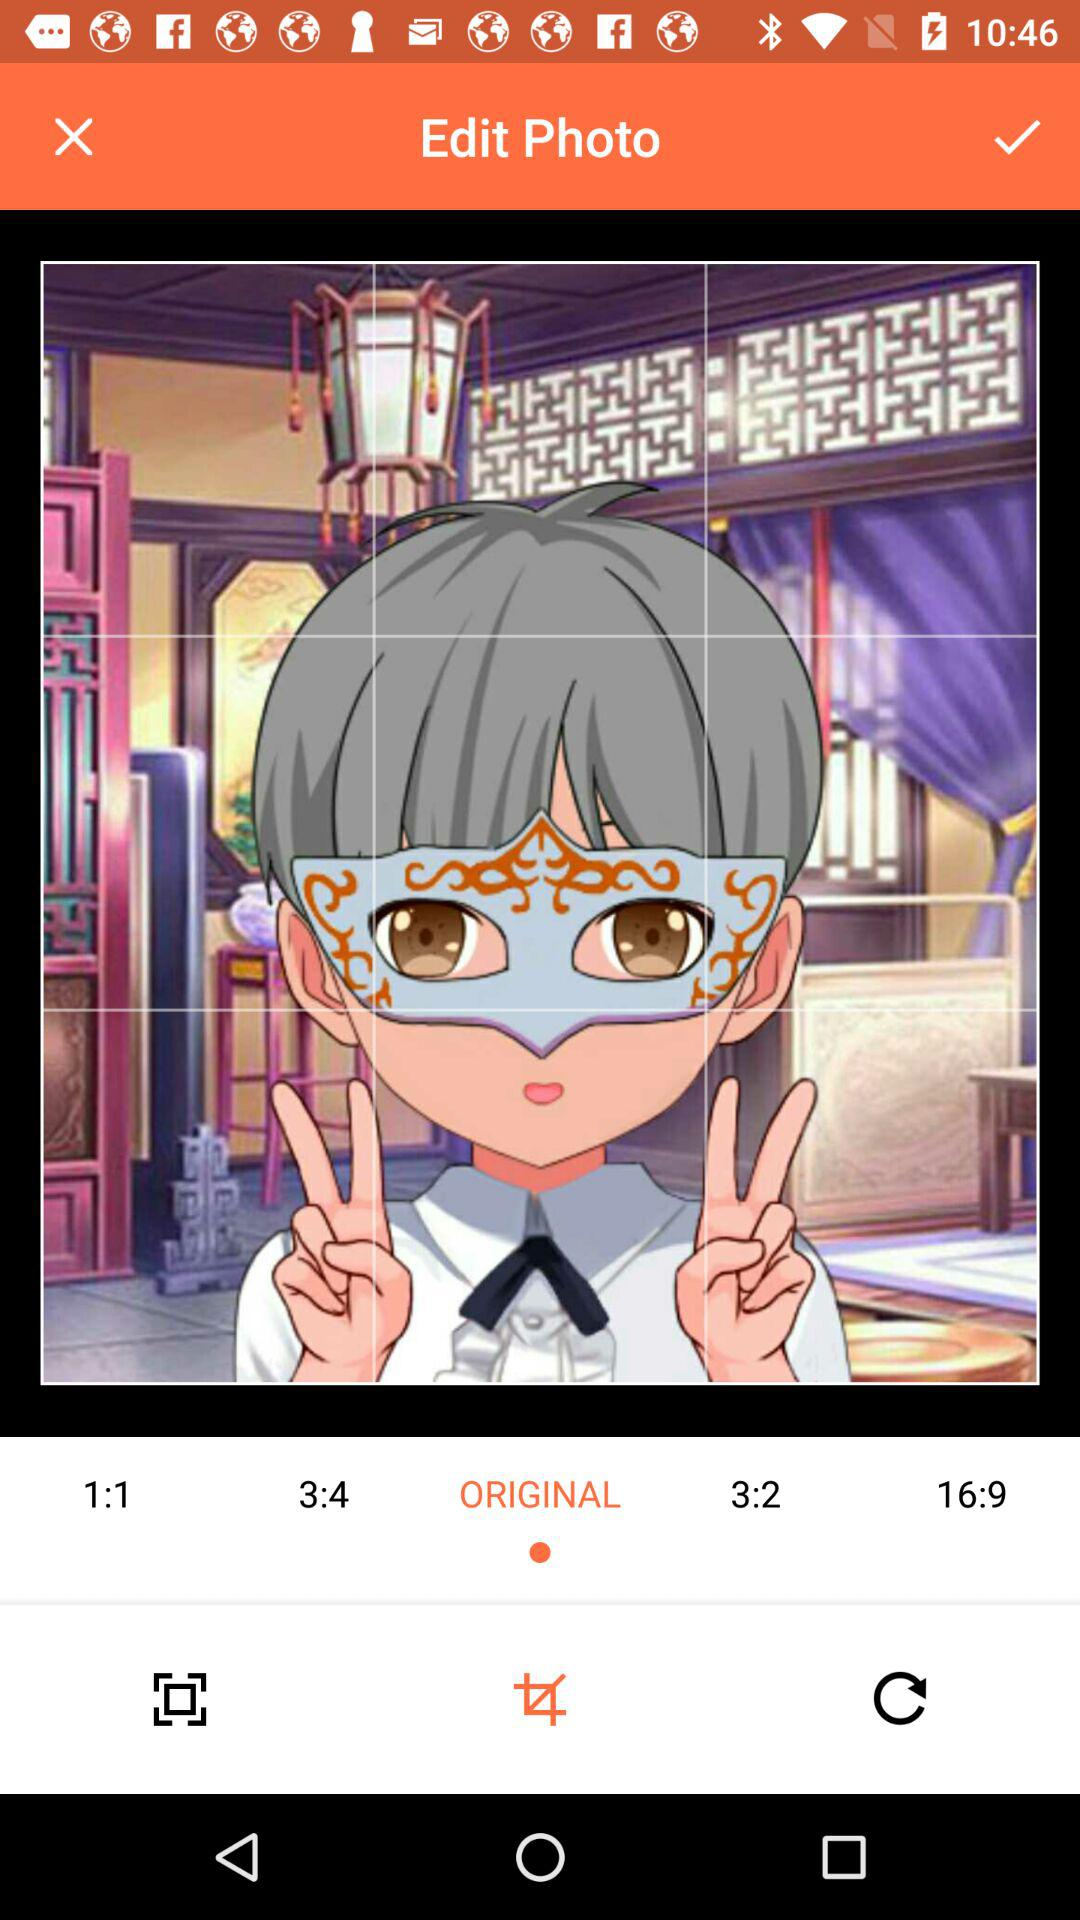What is the selected size of the photo? The selected size of the photo is "ORIGINAL". 